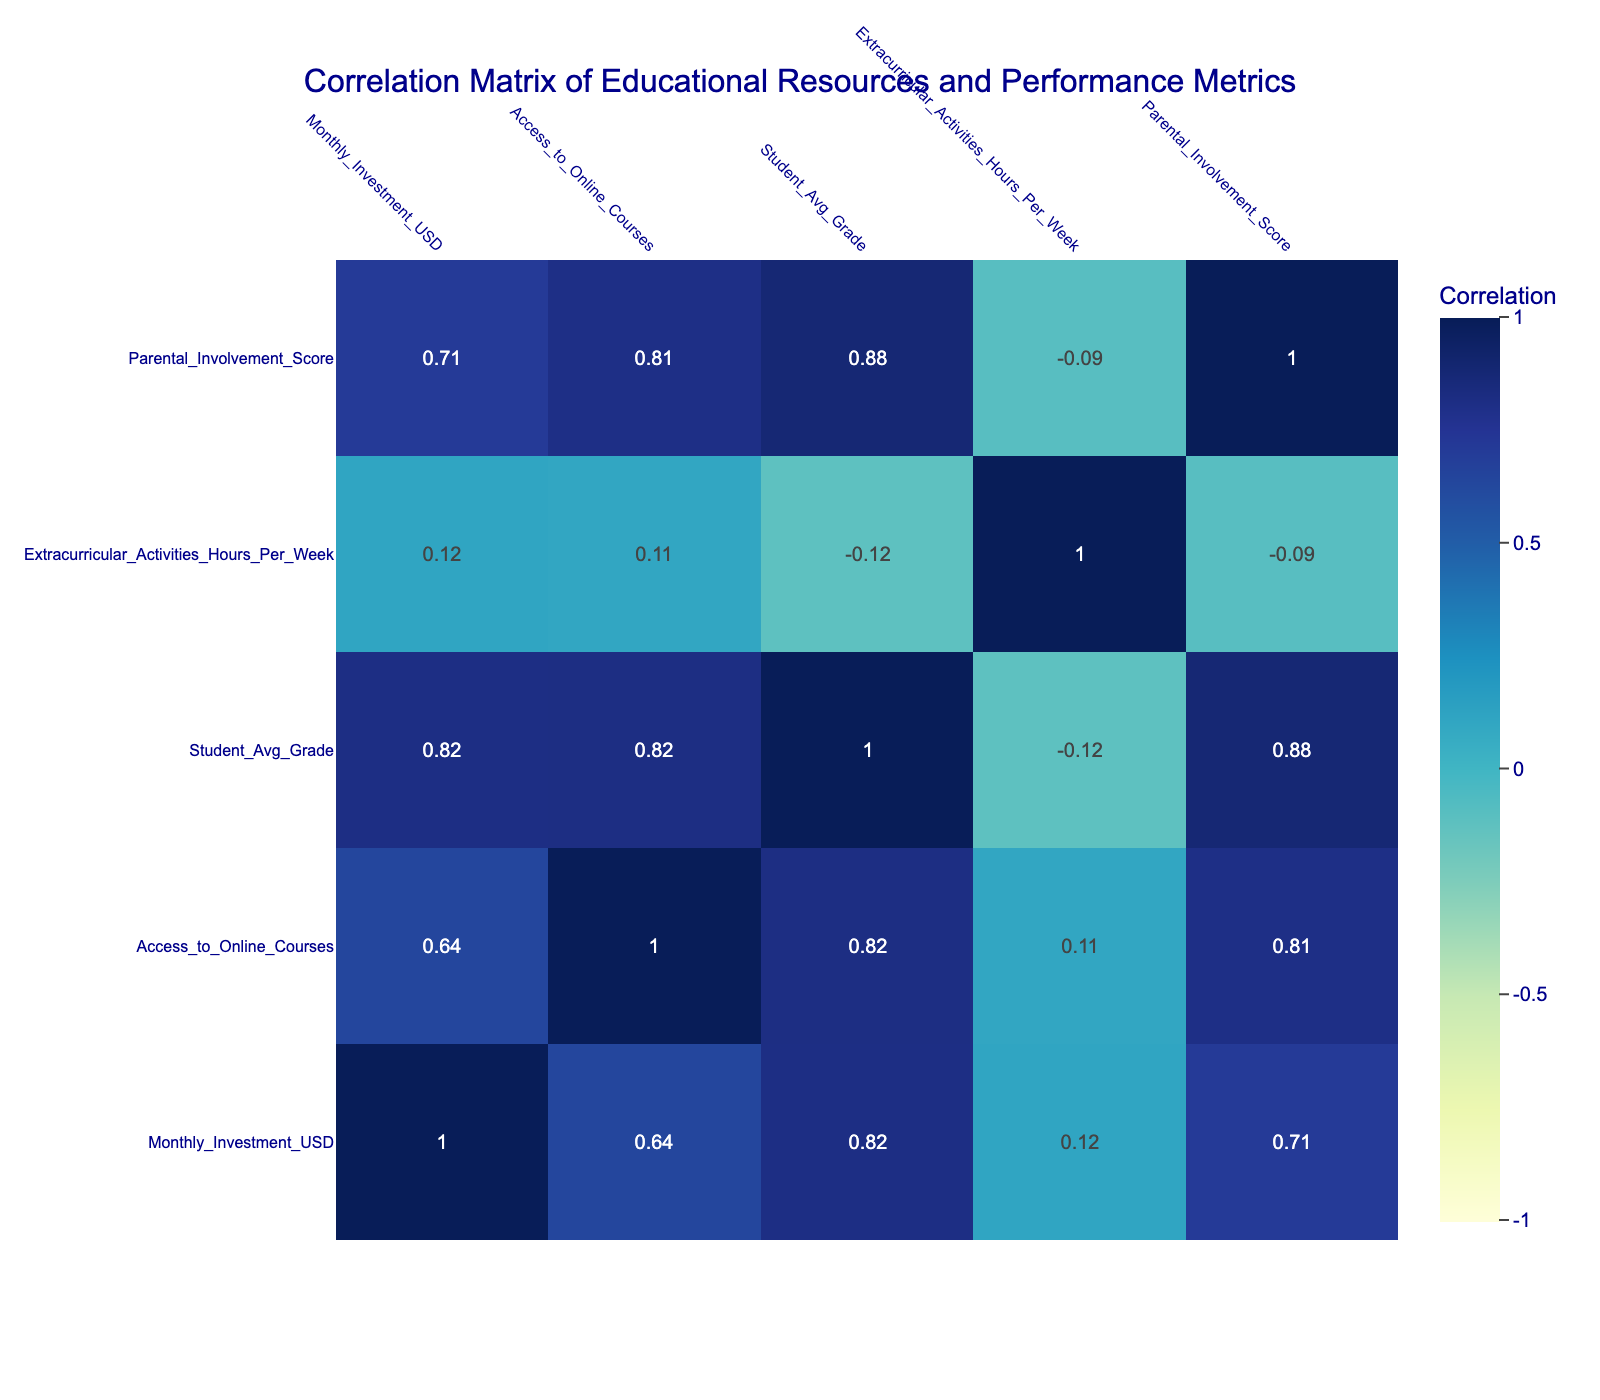What is the highest average grade achieved among the resource allocations? By examining the "Student_Avg_Grade" column, I identify the highest value listed. The highest average grade is 92, associated with the "STEM_Programs_Funding."
Answer: 92 What is the correlation between "Monthly_Investment_USD" and "Student_Avg_Grade"? In the correlation matrix, I check the cell where "Monthly_Investment_USD" and "Student_Avg_Grade" intersect. The value is 0.69, suggesting a moderate positive correlation, meaning as the investment increases, average grades tend to be higher.
Answer: 0.69 Is there a positive correlation between "Parental_Involvement_Score" and "Student_Avg_Grade"? The correlation matrix indicates a value of 0.89 between "Parental_Involvement_Score" and "Student_Avg_Grade." This indicates a strong positive correlation, meaning higher parental involvement is related to better student grades.
Answer: Yes What is the average "Monthly_Investment_USD" for resources that include online access? First, I filter the rows where "Access_to_Online_Courses" is 1: these are Library_Books, Online_Tutoring_Services, STEM_Programs_Funding, Field_Trip_Sponsorship, Technology_Grants, Counseling_Services, and Parent_Workshops. Their investments are: 500, 700, 600, 250, 400, 450, 350, totaling 3950. Then, I divide this by the count (7) to find the average: 3950/7 = 564.29. Thus, the average investment for resources with online access is approximately 564.29 USD.
Answer: 564.29 How many hours of extracurricular activities are averaged across all resources? I sum the "Extracurricular_Activities_Hours_Per_Week" values (3 + 2 + 4 + 5 + 2 + 1 + 0 + 1 + 3 + 2) to get 23 hours collectively across 10 resources. Dividing this total by the number of resources (10), the average is 23/10 = 2.3 hours/week.
Answer: 2.3 Does increasing investment in "Sports_Equipment_Funding" correlate negatively with "Student_Avg_Grade"? Checking the correlation matrix, the correlation value between "Sports_Equipment_Funding" and "Student_Avg_Grade" is -0.45. This negative value indicates that as the investment in sports equipment increases, the average grade tends to decrease, albeit weakly.
Answer: Yes What is the difference in average grades between resources with and without online access? First, I calculate the average grades for resources with online access (Library_Books, Online_Tutoring_Services, STEM_Programs_Funding, Field_Trip_Sponsorship, Technology_Grants, Counseling_Services, Parent_Workshops) which total: (88+90+92+87+91+89+86)/7 = 89.14. Then, I compute the average for those without online access (Art_Supplies, Music_Instruments): (80+82)/2 = 81. So the difference is: 89.14 - 81 = 8.14.
Answer: 8.14 